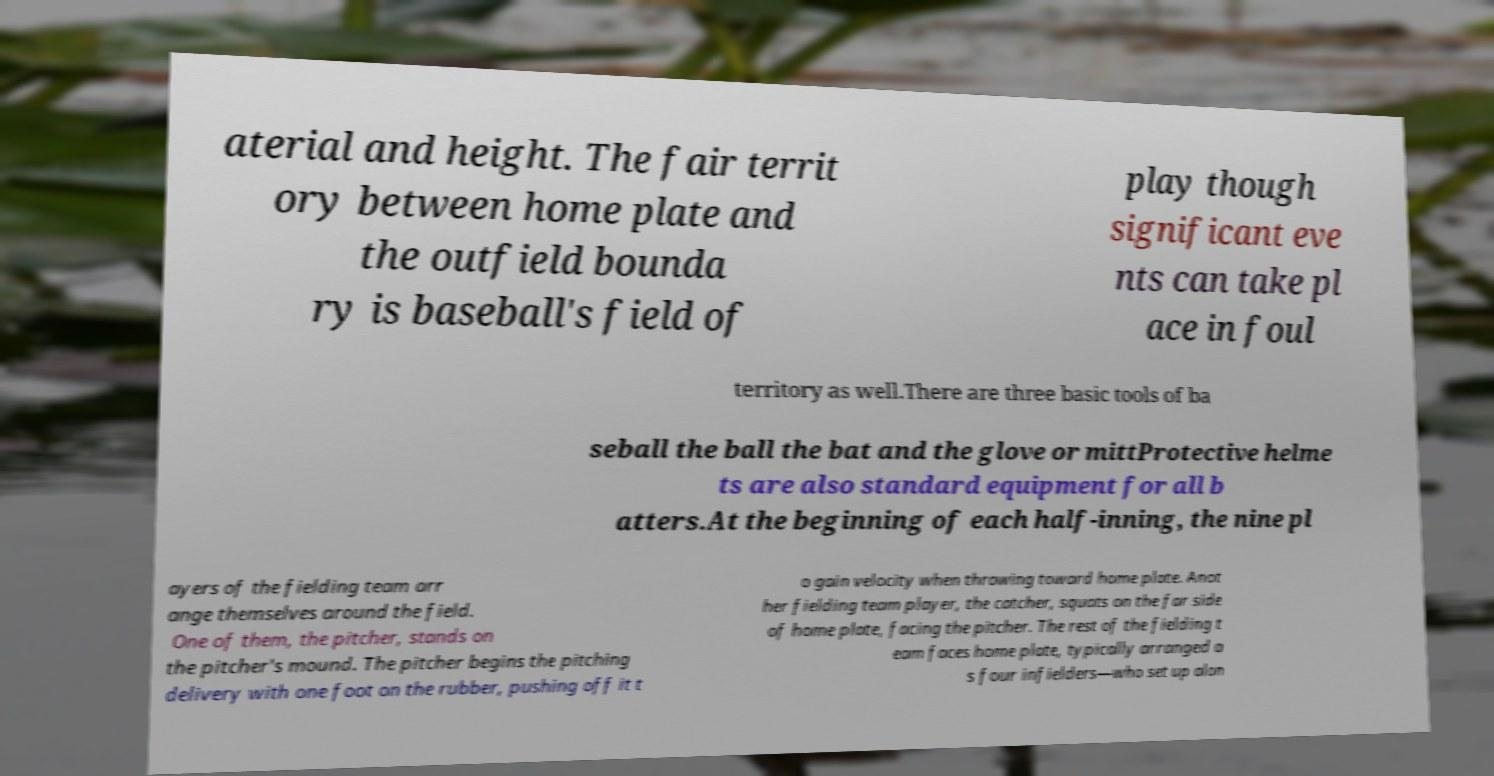What messages or text are displayed in this image? I need them in a readable, typed format. aterial and height. The fair territ ory between home plate and the outfield bounda ry is baseball's field of play though significant eve nts can take pl ace in foul territory as well.There are three basic tools of ba seball the ball the bat and the glove or mittProtective helme ts are also standard equipment for all b atters.At the beginning of each half-inning, the nine pl ayers of the fielding team arr ange themselves around the field. One of them, the pitcher, stands on the pitcher's mound. The pitcher begins the pitching delivery with one foot on the rubber, pushing off it t o gain velocity when throwing toward home plate. Anot her fielding team player, the catcher, squats on the far side of home plate, facing the pitcher. The rest of the fielding t eam faces home plate, typically arranged a s four infielders—who set up alon 